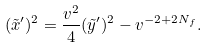Convert formula to latex. <formula><loc_0><loc_0><loc_500><loc_500>( \tilde { x } ^ { \prime } ) ^ { 2 } = \frac { v ^ { 2 } } { 4 } ( \tilde { y } ^ { \prime } ) ^ { 2 } - v ^ { - 2 + 2 N _ { f } } .</formula> 